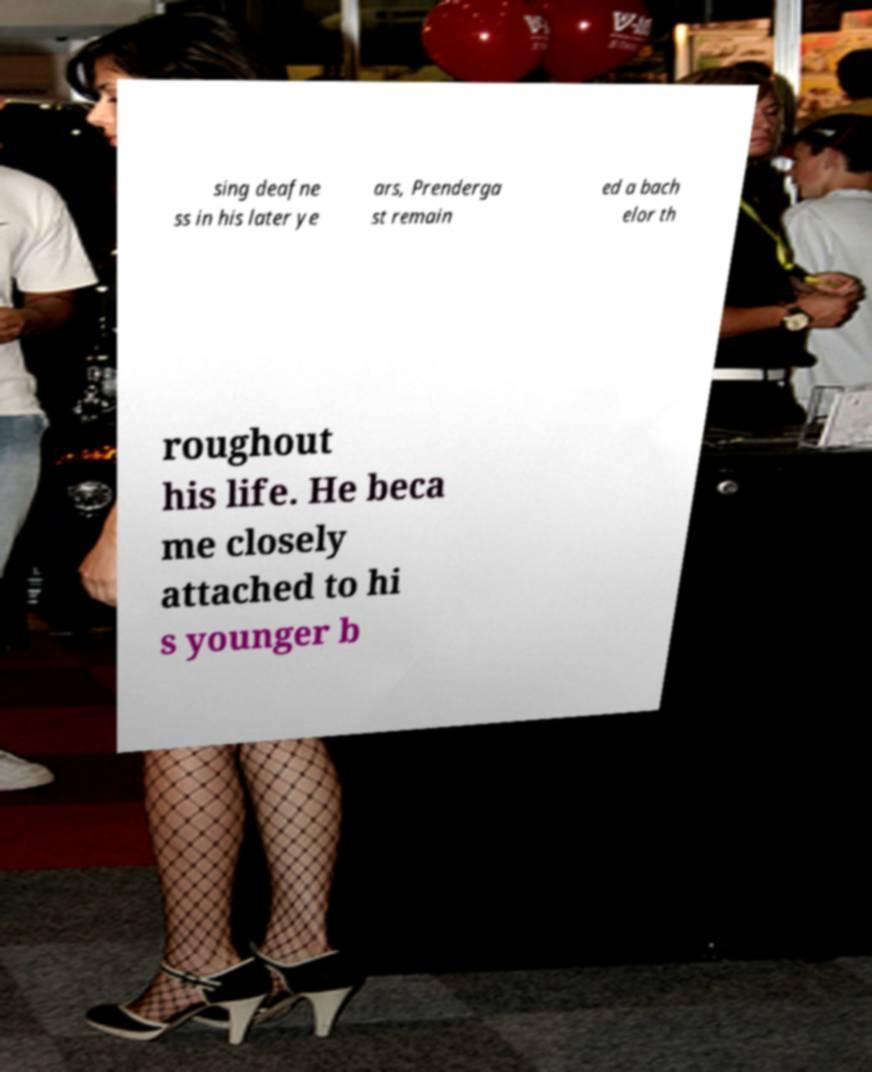Could you extract and type out the text from this image? sing deafne ss in his later ye ars, Prenderga st remain ed a bach elor th roughout his life. He beca me closely attached to hi s younger b 